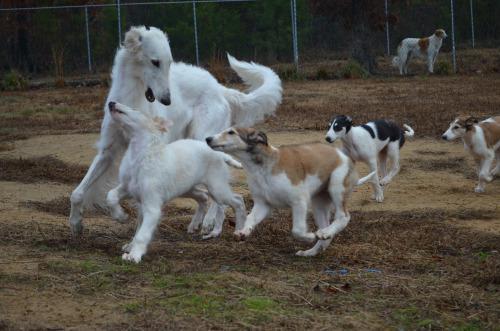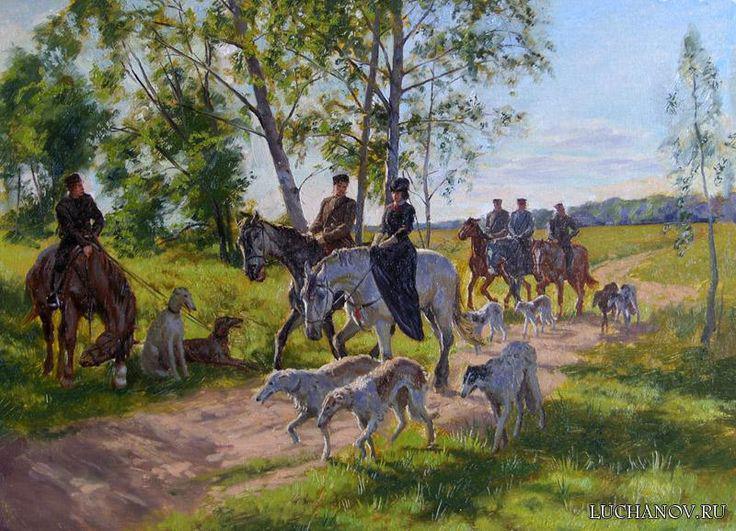The first image is the image on the left, the second image is the image on the right. Given the left and right images, does the statement "An image shows hounds standing on grass with a toy in the scene." hold true? Answer yes or no. No. 